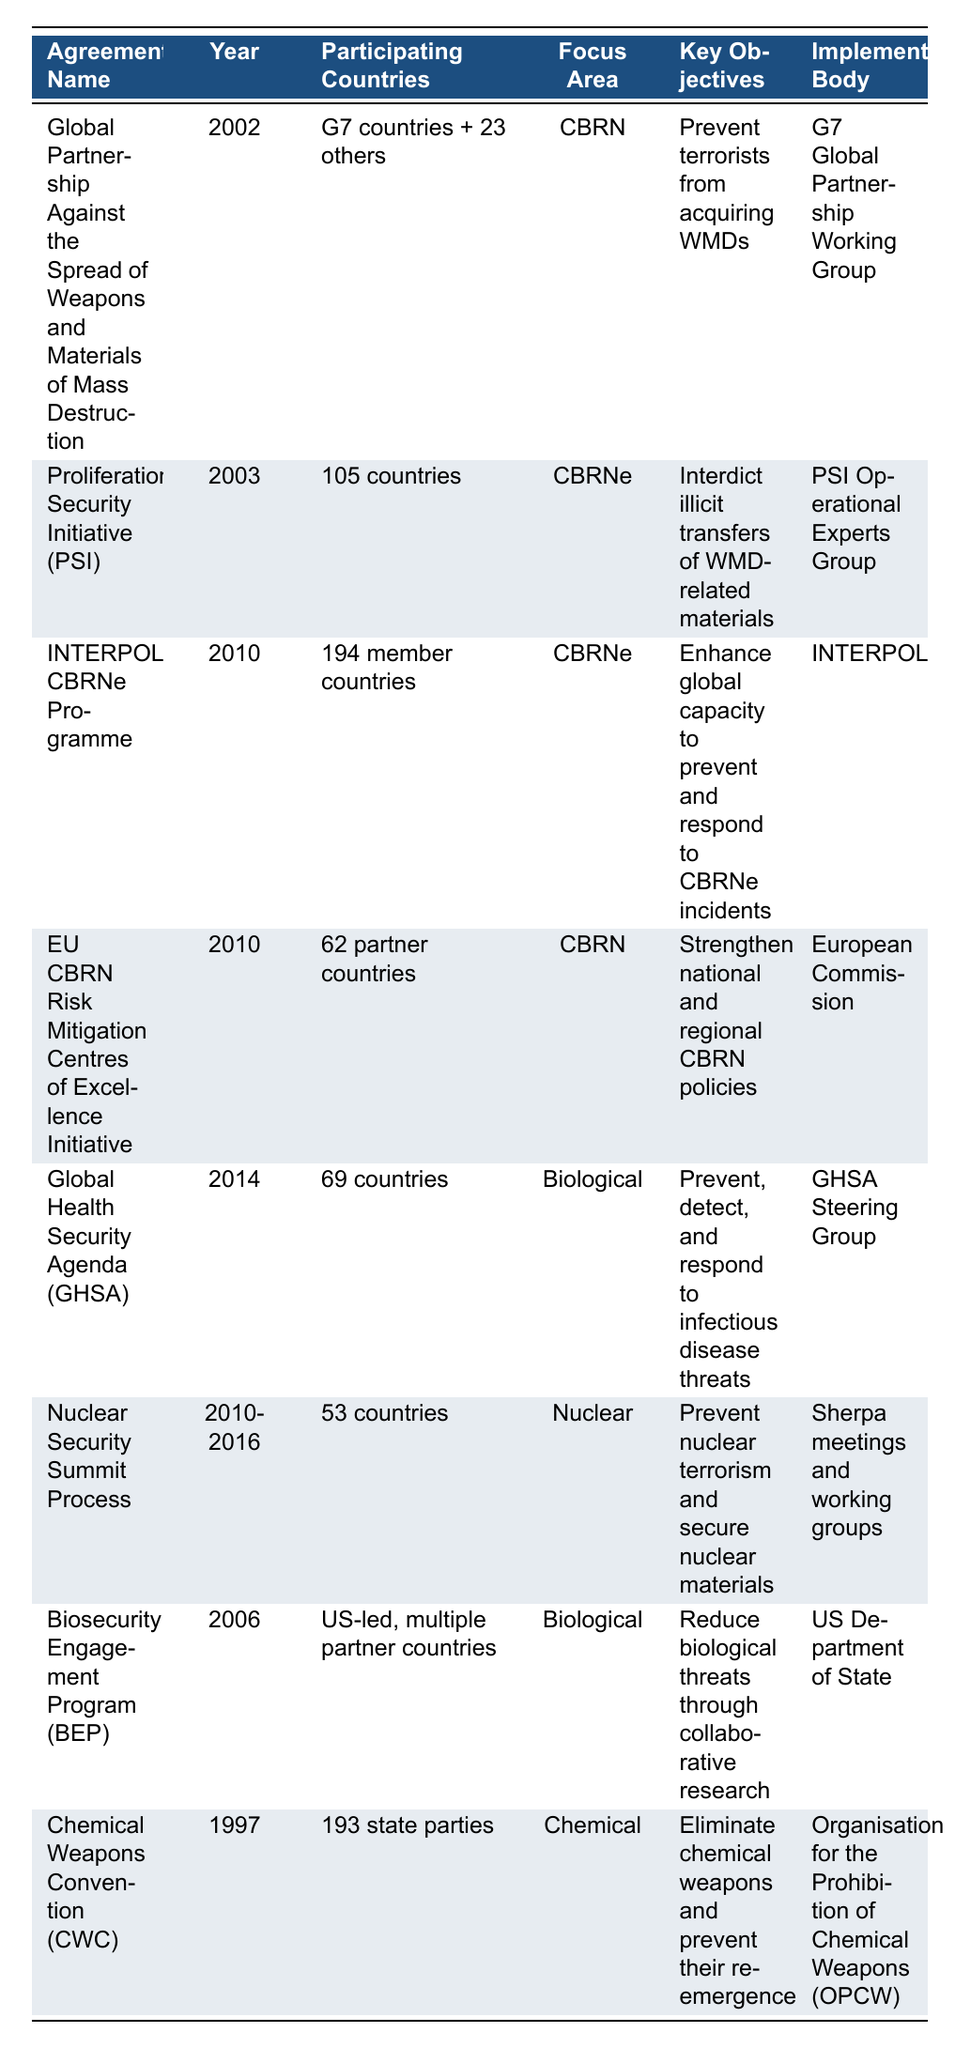What is the focus area of the "Chemical Weapons Convention (CWC)"? The table specifies that the focus area of the "Chemical Weapons Convention (CWC)" is "Chemical."
Answer: Chemical How many countries participated in the "Proliferation Security Initiative (PSI)"? The table indicates that 105 countries participated in the "Proliferation Security Initiative (PSI)."
Answer: 105 countries What year was the "Global Health Security Agenda (GHSA)" established? According to the table, the "Global Health Security Agenda (GHSA)" was established in 2014.
Answer: 2014 Which agreement has the highest number of participating countries? By comparing the data in the table, the "INTERPOL CBRNe Programme" has the highest number of participating countries with 194.
Answer: 194 Is the "Nuclear Security Summit Process" aimed at preventing nuclear terrorism? The table states that one of the key objectives of the "Nuclear Security Summit Process" is to prevent nuclear terrorism, which confirms the statement is true.
Answer: Yes How many agreements have a focus area related to biological threats? From the table, the agreements with a biological focus are the "Global Health Security Agenda (GHSA)" and the "Biosecurity Engagement Program (BEP)," totaling two agreements.
Answer: 2 What is the implementation body for the "EU CBRN Risk Mitigation Centres of Excellence Initiative"? The table lists the implementation body for the "EU CBRN Risk Mitigation Centres of Excellence Initiative" as the "European Commission."
Answer: European Commission Which agreement targets both chemical and biological threats? The table shows there are two separate agreements for biological threats and one for chemical, indicating that none of the agreements targets both chemical and biological threats simultaneously.
Answer: None What is the time span for the "Nuclear Security Summit Process"? The table indicates that the "Nuclear Security Summit Process" was active from 2010 to 2016, meaning it spanned 7 years.
Answer: 7 years How many agreements were established in or after the year 2010? By reviewing the table, agreements established in or after 2010 are the "INTERPOL CBRNe Programme," "EU CBRN Risk Mitigation Centres of Excellence Initiative," "Global Health Security Agenda (GHSA)," and the "Nuclear Security Summit Process," totaling four agreements.
Answer: 4 